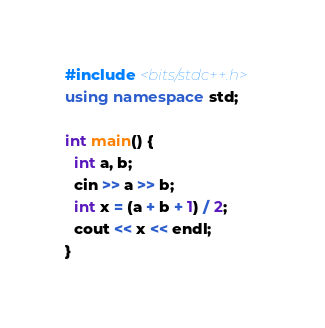Convert code to text. <code><loc_0><loc_0><loc_500><loc_500><_C++_>#include <bits/stdc++.h>
using namespace std;
 
int main() {
  int a, b;
  cin >> a >> b;
  int x = (a + b + 1) / 2;
  cout << x << endl;
}</code> 